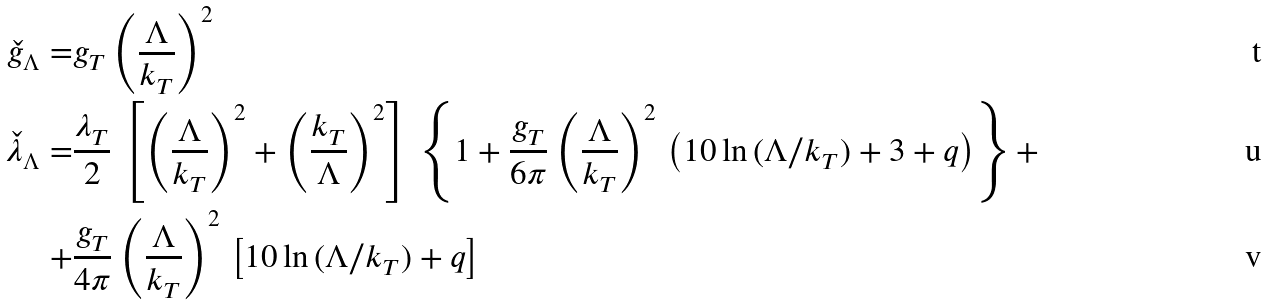Convert formula to latex. <formula><loc_0><loc_0><loc_500><loc_500>\check { g } _ { \Lambda } = & g _ { T } \left ( \frac { \Lambda } { k _ { T } } \right ) ^ { 2 } \\ \check { \lambda } _ { \Lambda } = & \frac { \lambda _ { T } } { 2 } \, \left [ \left ( \frac { \Lambda } { k _ { T } } \right ) ^ { 2 } + \left ( \frac { k _ { T } } { \Lambda } \right ) ^ { 2 } \right ] \, \left \{ 1 + \frac { g _ { T } } { 6 \pi } \left ( \frac { \Lambda } { k _ { T } } \right ) ^ { 2 } \, \left ( 1 0 \ln { ( \Lambda / k _ { T } ) } + 3 + q \right ) \right \} + \\ + & \frac { g _ { T } } { 4 \pi } \left ( \frac { \Lambda } { k _ { T } } \right ) ^ { 2 } \, \left [ 1 0 \ln { ( \Lambda / k _ { T } ) } + q \right ]</formula> 